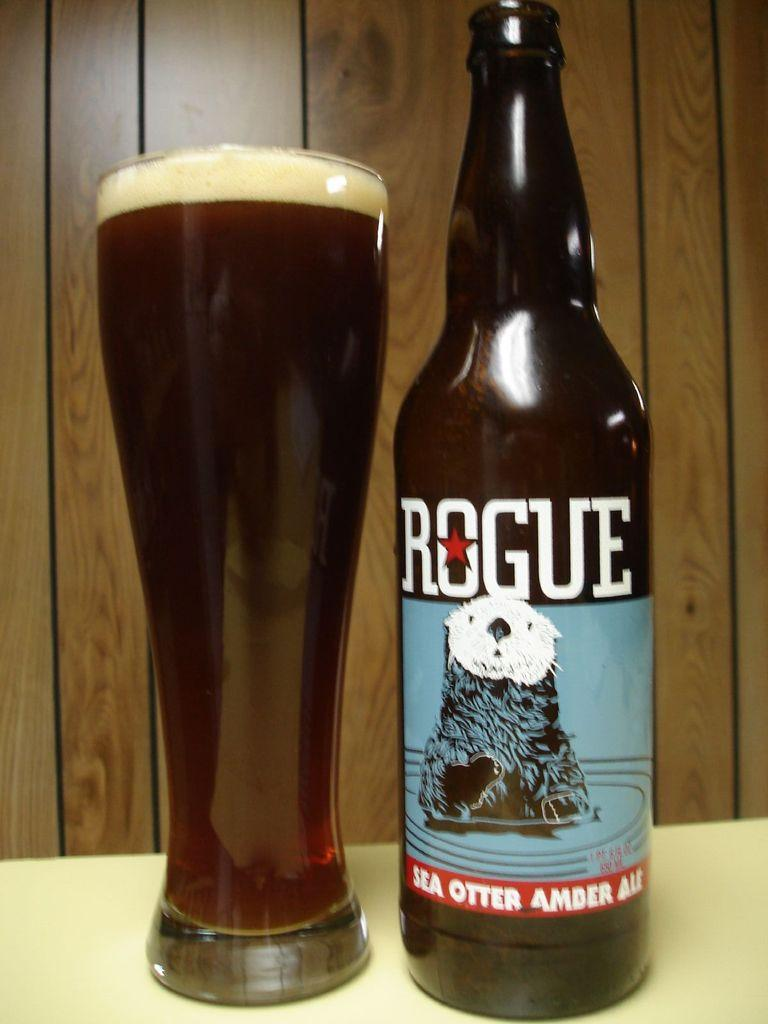<image>
Write a terse but informative summary of the picture. Bottle with a label that says Rogue on it next to a cup of beer. 